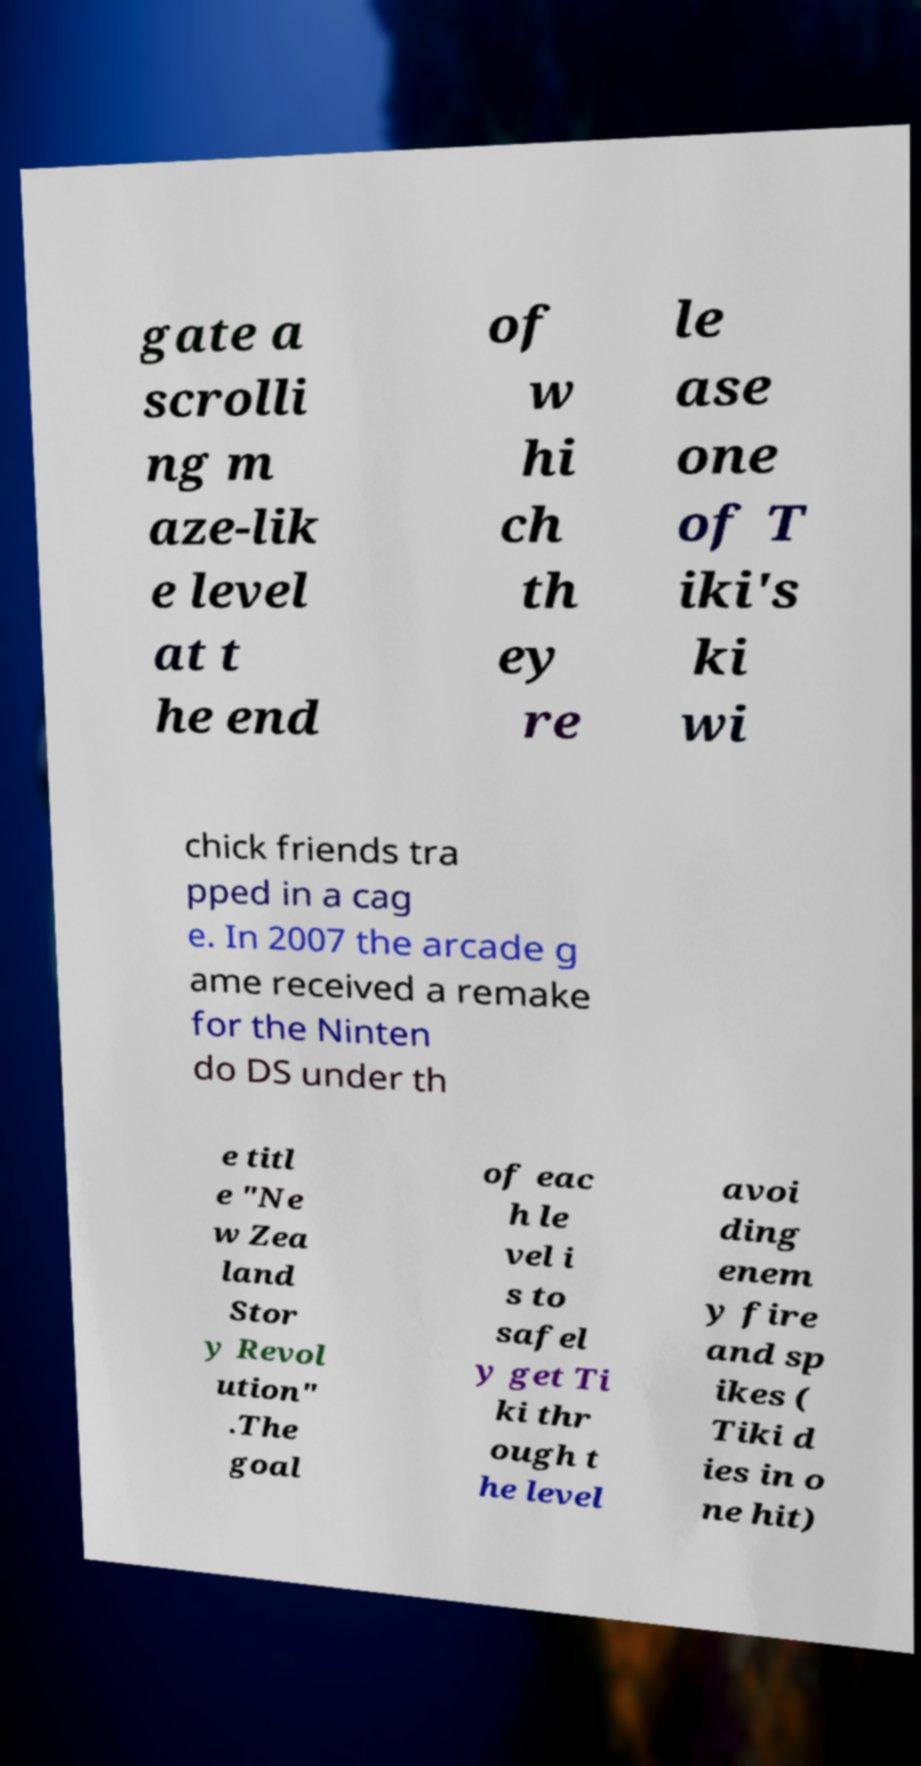Can you accurately transcribe the text from the provided image for me? gate a scrolli ng m aze-lik e level at t he end of w hi ch th ey re le ase one of T iki's ki wi chick friends tra pped in a cag e. In 2007 the arcade g ame received a remake for the Ninten do DS under th e titl e "Ne w Zea land Stor y Revol ution" .The goal of eac h le vel i s to safel y get Ti ki thr ough t he level avoi ding enem y fire and sp ikes ( Tiki d ies in o ne hit) 